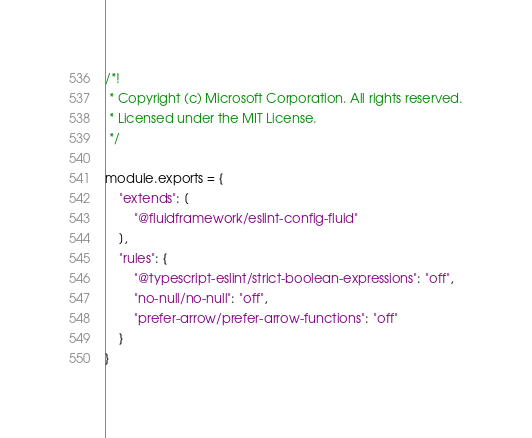Convert code to text. <code><loc_0><loc_0><loc_500><loc_500><_JavaScript_>/*!
 * Copyright (c) Microsoft Corporation. All rights reserved.
 * Licensed under the MIT License.
 */

module.exports = {
    "extends": [
        "@fluidframework/eslint-config-fluid"
    ],
    "rules": {
        "@typescript-eslint/strict-boolean-expressions": "off",
        "no-null/no-null": "off",
        "prefer-arrow/prefer-arrow-functions": "off"
    }
}</code> 